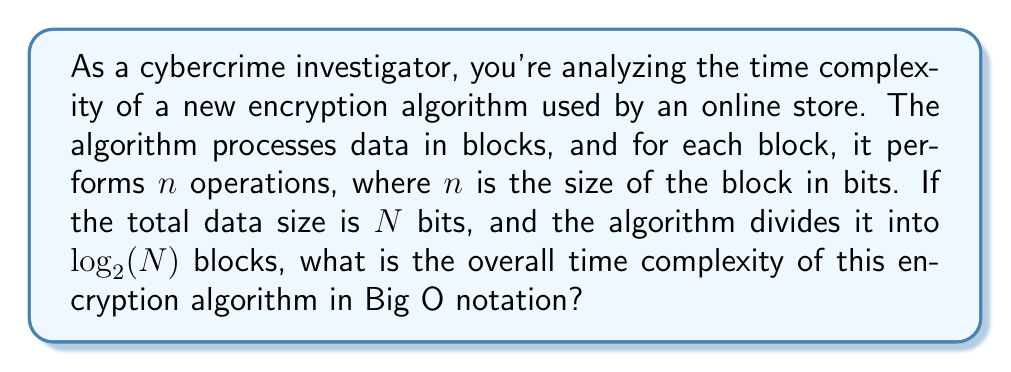What is the answer to this math problem? Let's approach this step-by-step:

1) The total data size is $N$ bits.

2) The data is divided into $\log_2(N)$ blocks.

3) For each block, the algorithm performs $n$ operations, where $n$ is the size of the block.

4) To find $n$, we need to calculate the size of each block:
   $n = \frac{N}{\log_2(N)}$ (total size divided by number of blocks)

5) The total number of operations is:
   $(\text{number of blocks}) \times (\text{operations per block})$
   $= \log_2(N) \times \frac{N}{\log_2(N)}$

6) Simplifying:
   $\log_2(N) \times \frac{N}{\log_2(N)} = N$

7) Therefore, the time complexity is $O(N)$.

This means the time complexity is linear with respect to the input size, which is efficient for an encryption algorithm.
Answer: $O(N)$ 